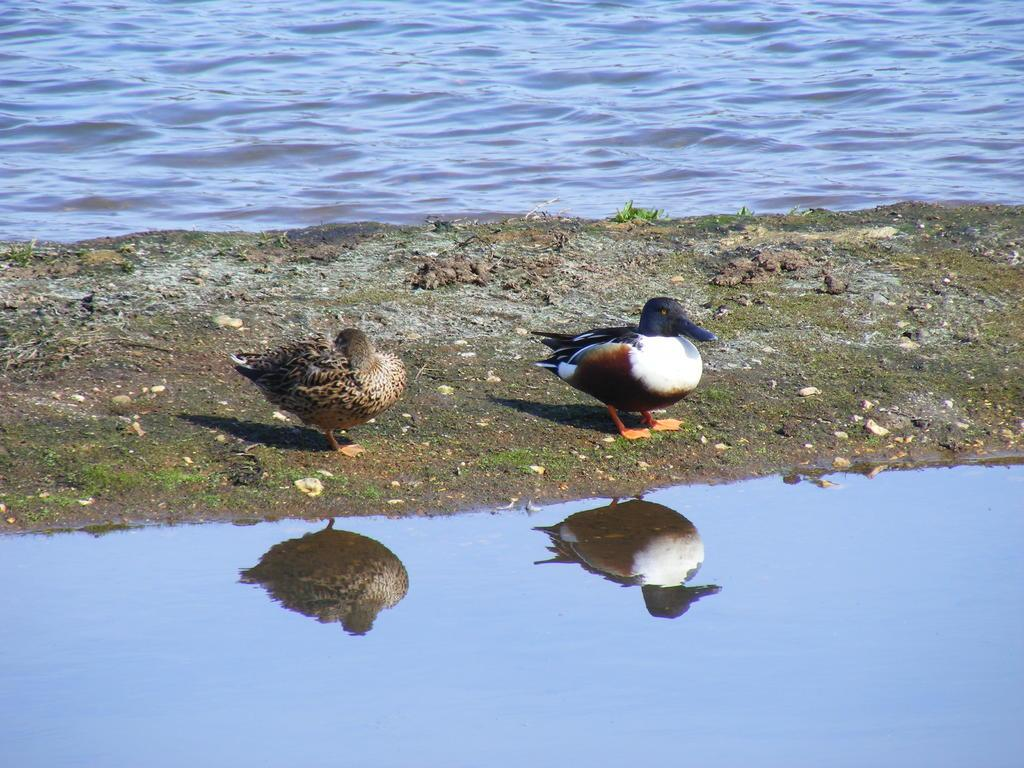What type of animals can be seen on the land in the image? There are birds on the land in the image. What natural element is present on both sides of the image? Water is visible on both sides of the image. What year is depicted in the image? The image does not depict a specific year; it is a photograph of birds and water. Is there a railway visible in the image? There is no railway present in the image. 